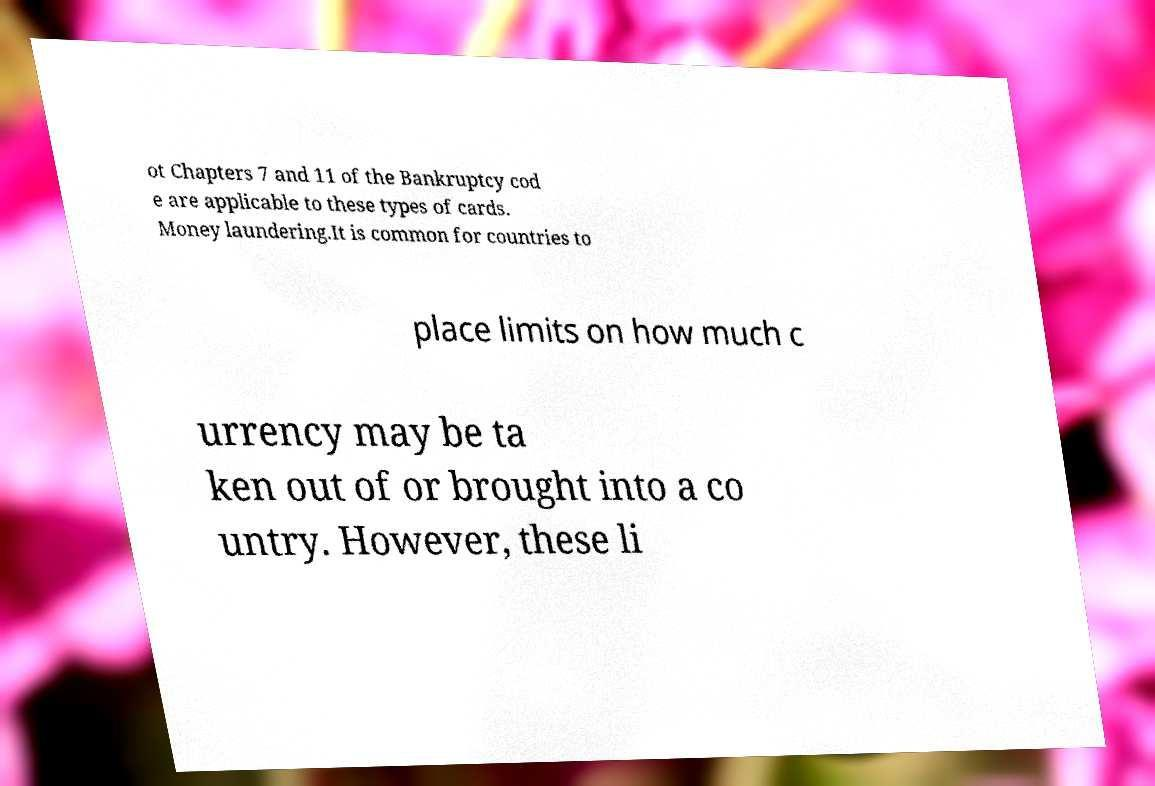Can you accurately transcribe the text from the provided image for me? ot Chapters 7 and 11 of the Bankruptcy cod e are applicable to these types of cards. Money laundering.It is common for countries to place limits on how much c urrency may be ta ken out of or brought into a co untry. However, these li 